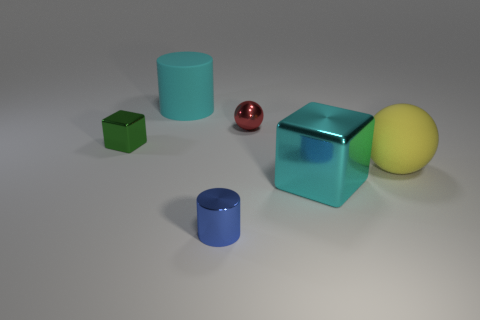Add 4 big yellow cylinders. How many objects exist? 10 Subtract all cylinders. How many objects are left? 4 Subtract all cyan cylinders. Subtract all balls. How many objects are left? 3 Add 2 red shiny spheres. How many red shiny spheres are left? 3 Add 6 tiny metal cubes. How many tiny metal cubes exist? 7 Subtract 0 blue spheres. How many objects are left? 6 